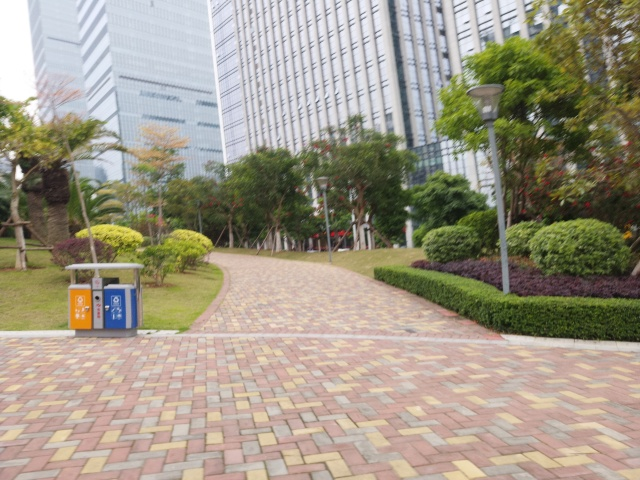Is the image blurry?
 No 